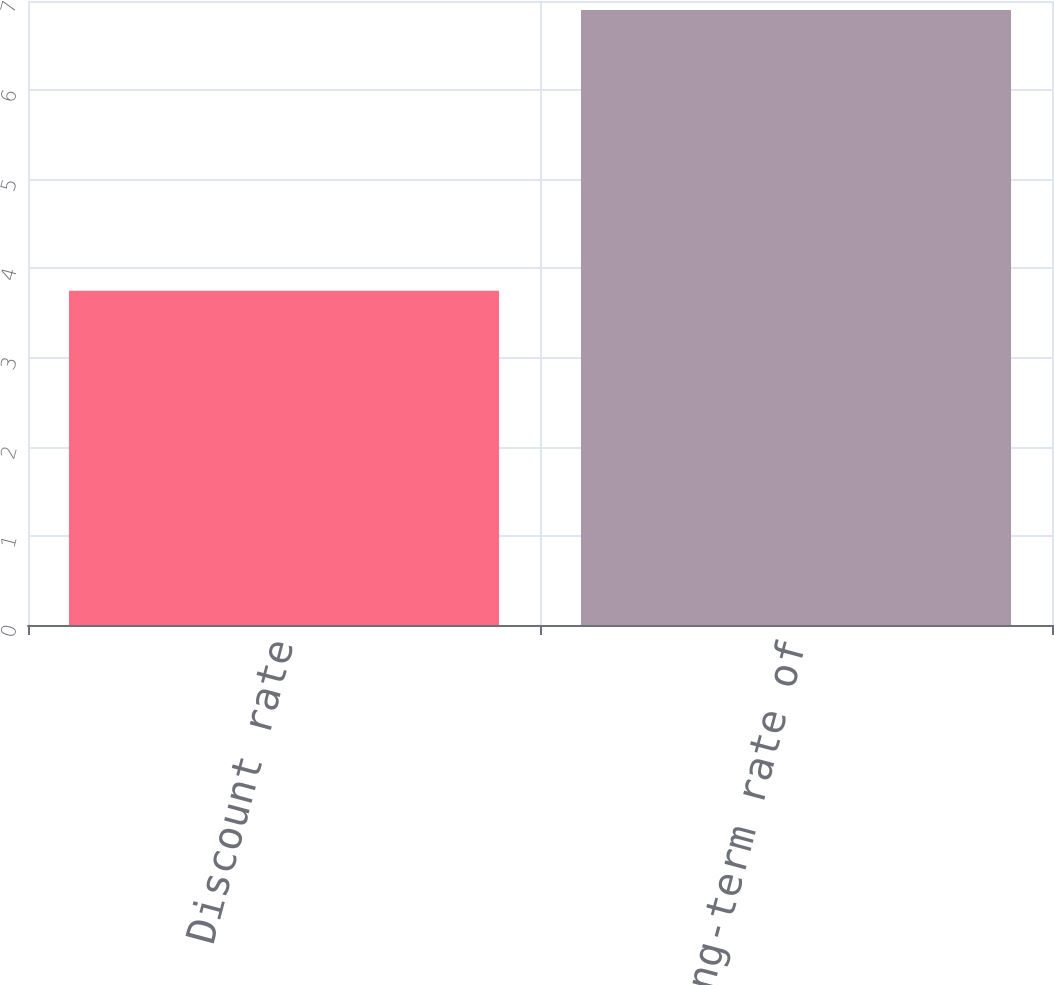<chart> <loc_0><loc_0><loc_500><loc_500><bar_chart><fcel>Discount rate<fcel>Expected long-term rate of<nl><fcel>3.75<fcel>6.9<nl></chart> 